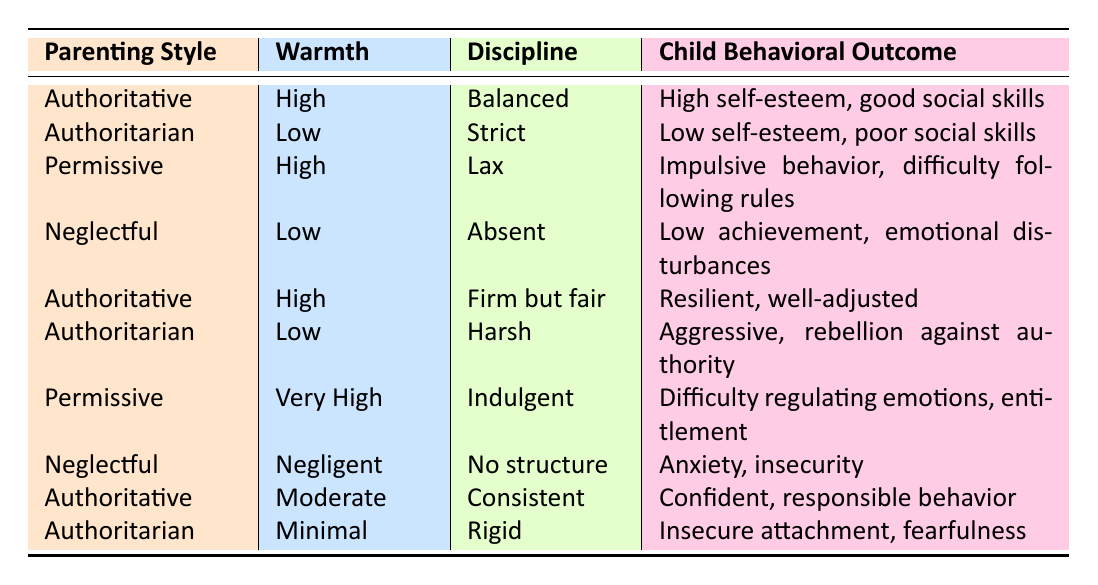What are the child behavioral outcomes of the Authoritative parenting style with high warmth and balanced discipline? Referring to the table, the Authoritative parenting style with high warmth and balanced discipline results in "High self-esteem, good social skills."
Answer: High self-esteem, good social skills How many different child behavioral outcomes are associated with Neglectful parenting? In the table, the Neglectful parenting style has two outcomes listed: "Low achievement, emotional disturbances" and "Anxiety, insecurity." Therefore, there are two distinct behavioral outcomes.
Answer: 2 Is it true that all Authoritarian parenting styles lead to low self-esteem in children? The table shows that both Authoritarian parenting styles are associated with low self-esteem and poor social skills, as well as aggressive behavior and rebellion against authority. Since both outcomes reference low self-esteem collectively, the statement holds true.
Answer: Yes Which parenting style has the highest warmth and what is its child behavioral outcome? By looking at the table, the parenting style with the highest warmth is Permissive, characterized by "Very High" warmth. The associated child behavioral outcome is "Difficulty regulating emotions, entitlement."
Answer: Permissive; Difficulty regulating emotions, entitlement What is the relationship between the level of warmth and the behavioral outcomes in the Authoritative parenting style? The Authoritative parenting style appears in three entries with varying warmth levels: High (with outcomes of high self-esteem, good social skills and resilient, well-adjusted), Moderate (with a confident, responsible behavior outcome), and the implication is that higher warmth generally correlates with more positive outcomes in children. Thus, a higher level of warmth is associated with better behavioral outcomes.
Answer: Higher warmth correlates with better outcomes 